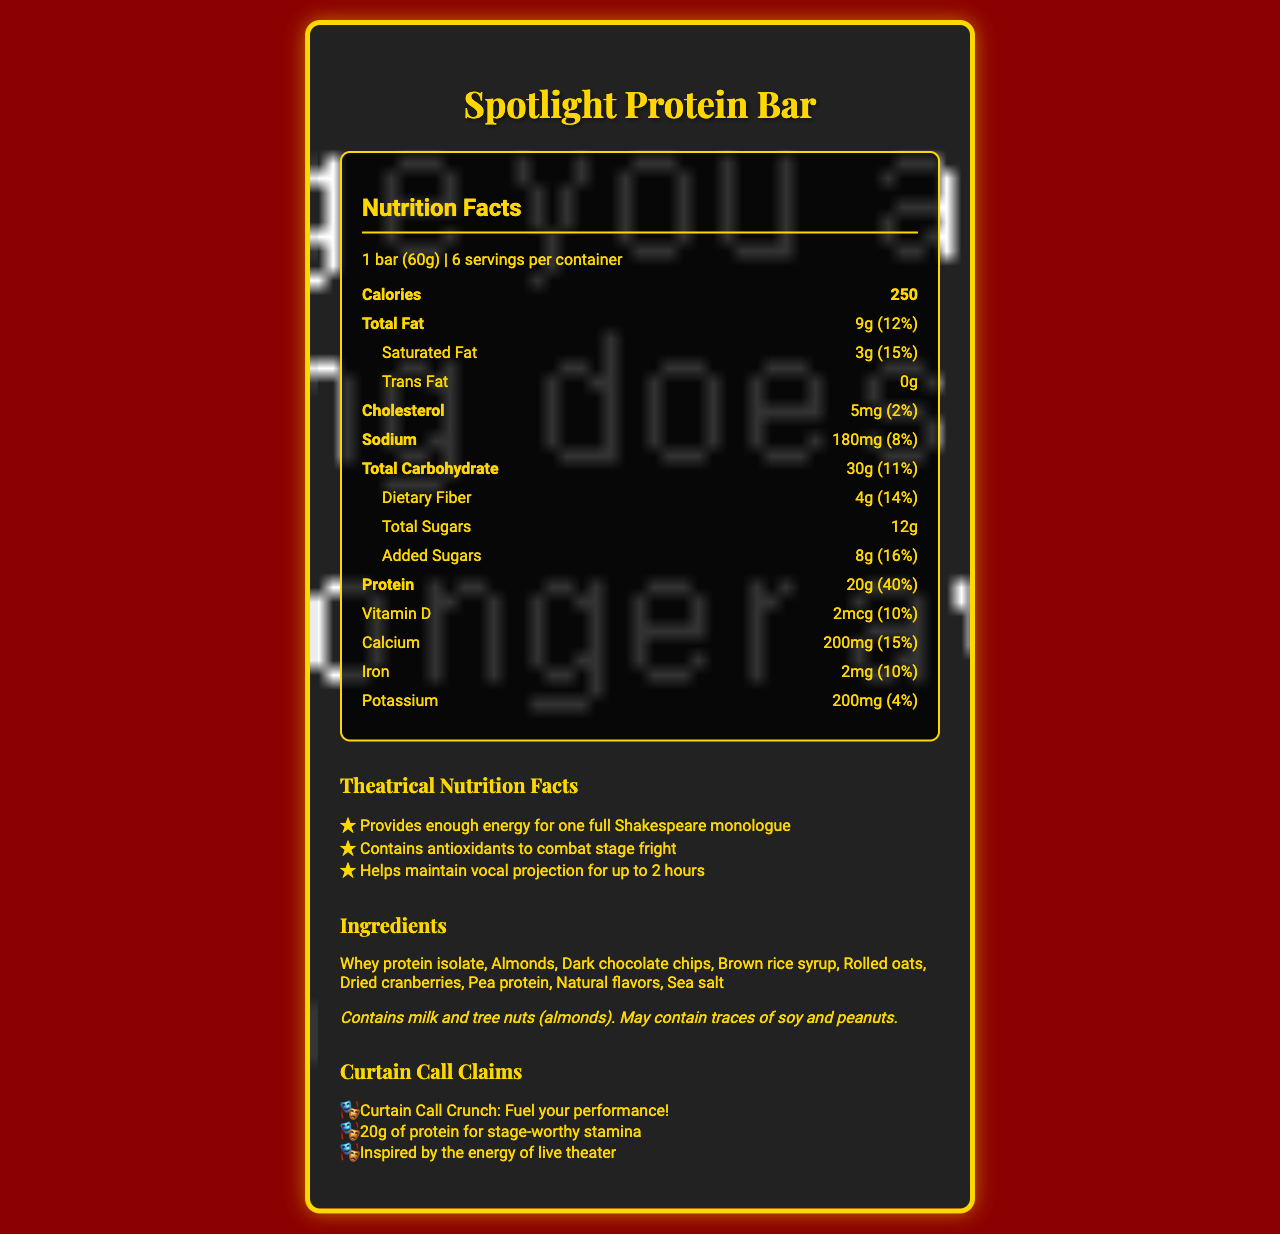what is the serving size of the Spotlight Protein Bar? The serving size is clearly stated in the nutrition facts section.
Answer: 1 bar (60g) how many servings are there per container? The document lists that there are 6 servings per container in the Spotlight Protein Bar.
Answer: 6 what is the amount of protein per serving? The nutrition label includes the protein content, which is 20g per serving.
Answer: 20g what percentage of your daily protein intake does one serving provide? The nutrition facts state that one serving provides 40% of the daily recommended protein intake.
Answer: 40% which ingredient is listed first in the ingredients section? The ingredients are listed in descending order by weight, and whey protein isolate is the first listed ingredient.
Answer: Whey protein isolate how much calcium is in one serving? The nutrition facts list calcium content as 200mg per serving.
Answer: 200mg what is the theme of the design used on the Spotlight Protein Bar's label? A. Jungle Expedition B. Space Adventure C. Red Velvet Curtain D. Underwater World The design theme is declared as "Red velvet curtain background."
Answer: C. Red Velvet Curtain how much added sugar is in one bar? A. 6g B. 7g C. 8g D. 9g The 'Added Sugars' section of the nutrition facts records 8g of added sugars.
Answer: C. 8g is the cholesterol amount more than 10mg per serving? The cholesterol content per serving is 5mg, which is less than 10mg.
Answer: No describe the main idea of the document The label provides comprehensive nutritional information along with a list of ingredients, allergens, and marketing claims, all presented within a theatrical design framework.
Answer: The document is a nutrition facts label for the Spotlight Protein Bar, designed with a theatrical theme incorporating elements such as a red velvet curtain background and Broadway-inspired lettering. It details the nutritional content per serving, including calories, fats, carbohydrates, proteins, and essential vitamins and minerals. It also includes marketing claims, theatrical nutrition facts, and allergen information. what is the total fat percentage in a serving? The nutrition facts section lists the total fat content and its daily value percentage, which is 12%.
Answer: 12% what professional audience might the Spotlight Protein Bar specifically cater to? The marketing claims and theatrical elements suggest that the protein bar is inspired by and caters to the energy needs of live theater performers.
Answer: Theater performers are almonds the only type of tree nut mentioned in the allergen information? The allergen information states that the bar contains milk and tree nuts, specifying almonds.
Answer: Yes how many grams of dietary fiber are in each serving of the bar? According to the nutrition facts, there are 4g of dietary fiber per serving.
Answer: 4g what is the calorie content for one serving of the Spotlight Protein Bar? The calorie content for one serving is listed in the nutrition facts section.
Answer: 250 what ingredient is used as a sweetener in the Spotlight Protein Bar? In the ingredients list, brown rice syrup is used as a sweetener.
Answer: Brown rice syrup how much sodium does one Spotlight Protein Bar contain? Sodium content per serving is stated as 180mg in the nutrition facts section.
Answer: 180mg which vitamin's percentage of daily value is the same as iron's? Both vitamin D and iron have a daily value percentage of 10%, as listed in the nutrition facts.
Answer: Vitamin D is the document describing a meal replacement? The document provides nutritional information for the Spotlight Protein Bar, but it does not specify if it is intended to be used as a meal replacement.
Answer: Cannot be determined 